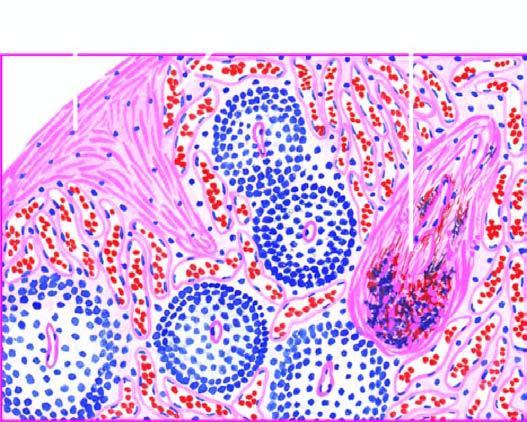where is increased fibrosis?
Answer the question using a single word or phrase. In the red pulp 